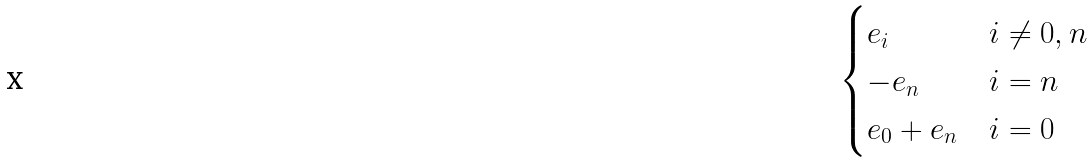<formula> <loc_0><loc_0><loc_500><loc_500>\begin{cases} e _ { i } & i \ne 0 , n \\ - e _ { n } & i = n \\ e _ { 0 } + e _ { n } & i = 0 \end{cases}</formula> 